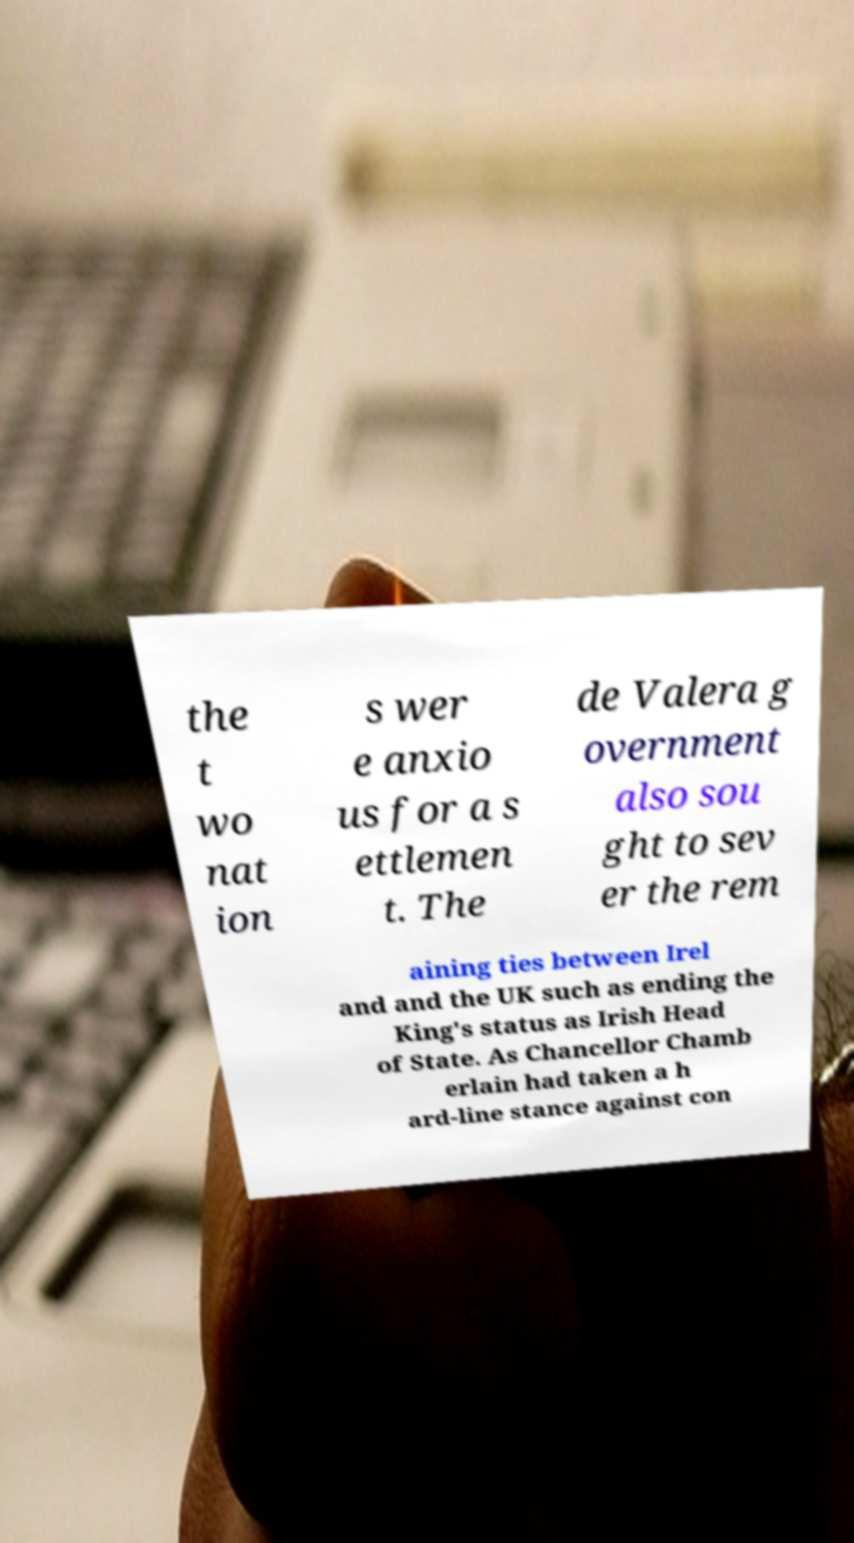Could you assist in decoding the text presented in this image and type it out clearly? the t wo nat ion s wer e anxio us for a s ettlemen t. The de Valera g overnment also sou ght to sev er the rem aining ties between Irel and and the UK such as ending the King's status as Irish Head of State. As Chancellor Chamb erlain had taken a h ard-line stance against con 